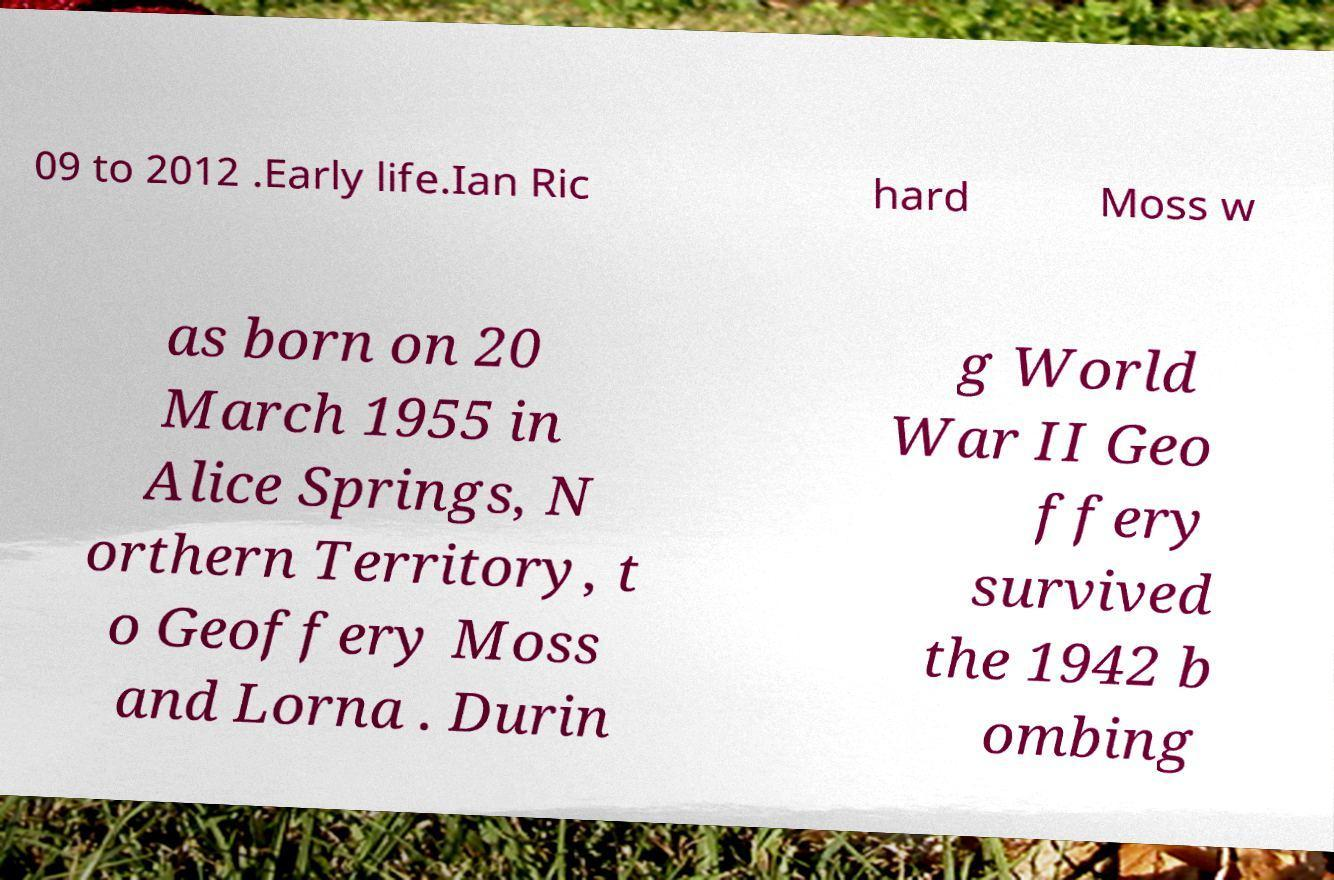Please identify and transcribe the text found in this image. 09 to 2012 .Early life.Ian Ric hard Moss w as born on 20 March 1955 in Alice Springs, N orthern Territory, t o Geoffery Moss and Lorna . Durin g World War II Geo ffery survived the 1942 b ombing 